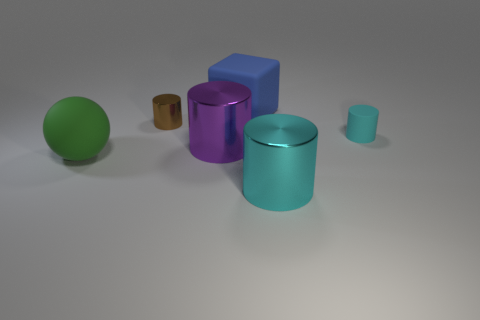The big thing that is on the right side of the large matte thing that is on the right side of the tiny metallic cylinder is made of what material?
Make the answer very short. Metal. What is the material of the big object that is both in front of the purple shiny object and on the right side of the tiny shiny cylinder?
Keep it short and to the point. Metal. Is there a green matte object of the same shape as the big purple object?
Your answer should be very brief. No. Is there a tiny cyan cylinder in front of the shiny object that is behind the purple metal thing?
Keep it short and to the point. Yes. How many big objects have the same material as the big cyan cylinder?
Your answer should be very brief. 1. Are any large rubber blocks visible?
Your answer should be very brief. Yes. What number of things are the same color as the rubber cylinder?
Your answer should be very brief. 1. Does the cube have the same material as the big cylinder behind the big cyan metal thing?
Provide a short and direct response. No. Are there more big blocks in front of the big cyan metal thing than cyan blocks?
Provide a short and direct response. No. Is the color of the big matte ball the same as the big thing behind the matte cylinder?
Provide a succinct answer. No. 